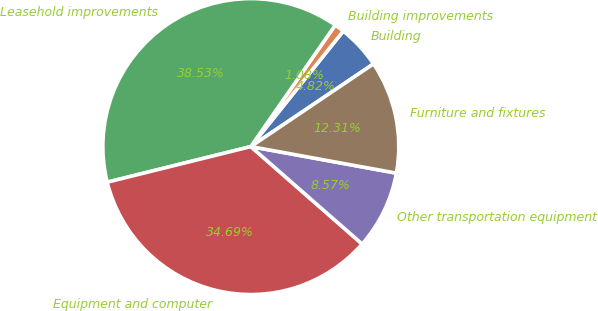<chart> <loc_0><loc_0><loc_500><loc_500><pie_chart><fcel>Building<fcel>Building improvements<fcel>Leasehold improvements<fcel>Equipment and computer<fcel>Other transportation equipment<fcel>Furniture and fixtures<nl><fcel>4.82%<fcel>1.08%<fcel>38.53%<fcel>34.69%<fcel>8.57%<fcel>12.31%<nl></chart> 